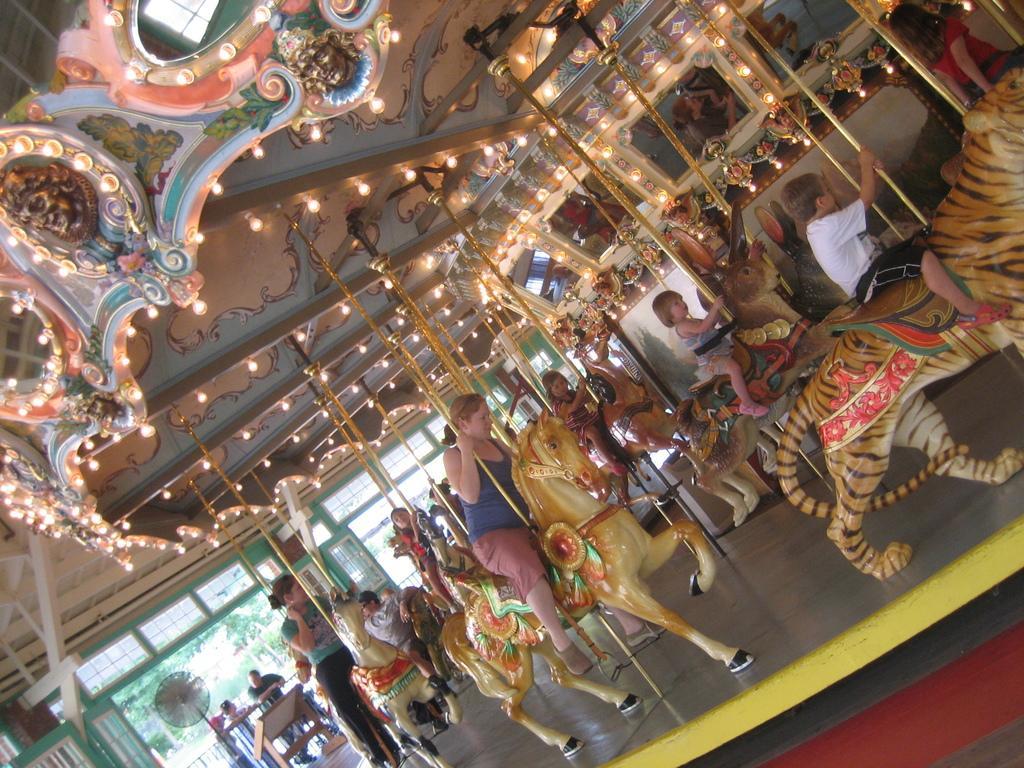Can you describe this image briefly? Here in this picture we can see a carousel present over there and on that we can see some children and people sitting over there and we can see it is fully decorated with lights over there and in the far we can see other people also standing over there and we can also see a table fan present over there and we can also see plants and trees in the far over there. 